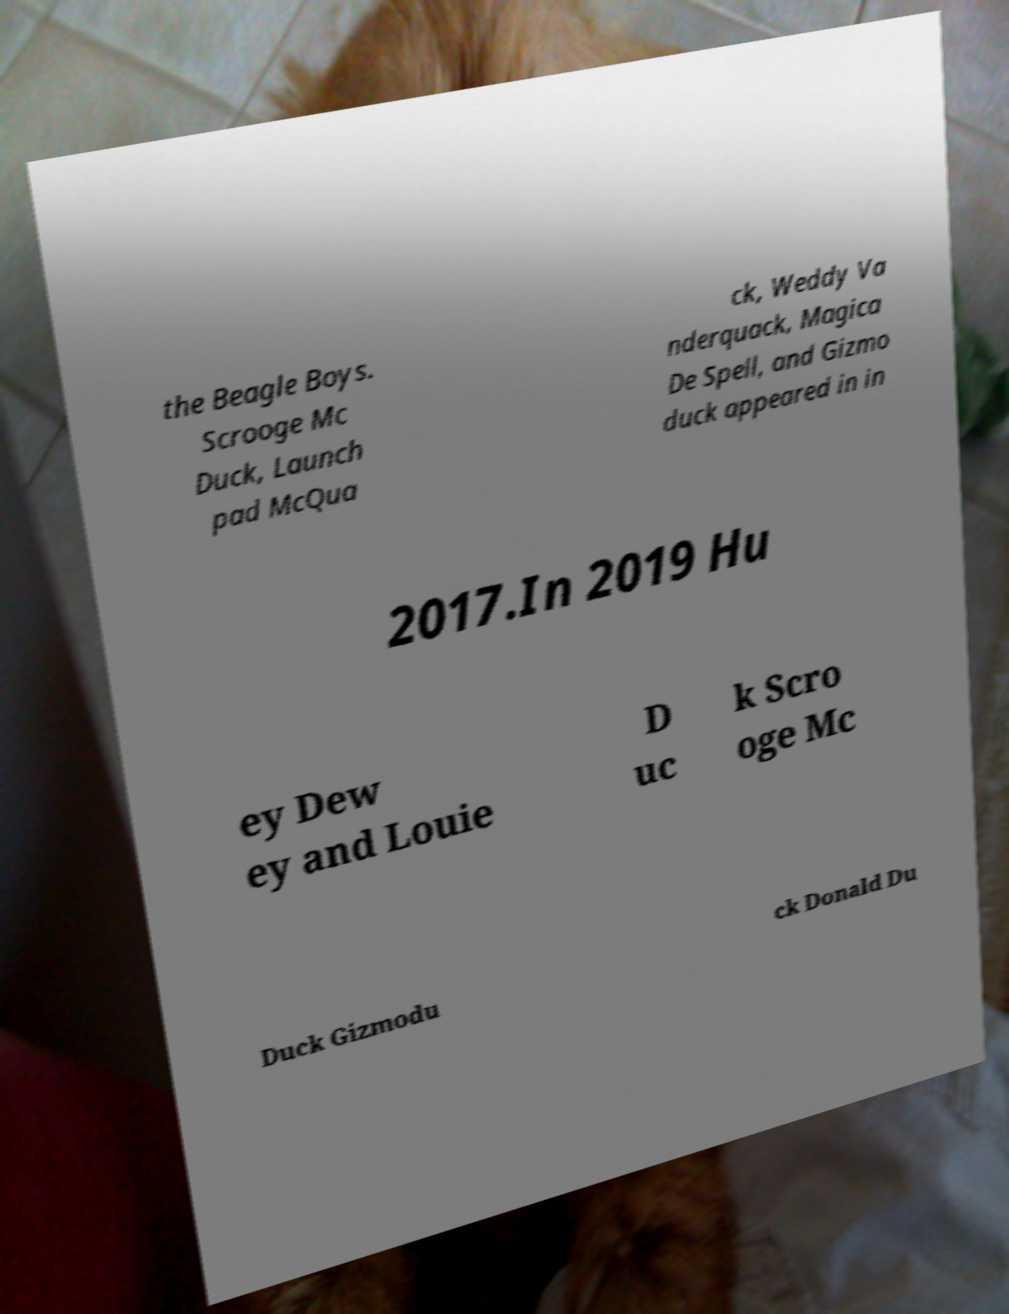Could you assist in decoding the text presented in this image and type it out clearly? the Beagle Boys. Scrooge Mc Duck, Launch pad McQua ck, Weddy Va nderquack, Magica De Spell, and Gizmo duck appeared in in 2017.In 2019 Hu ey Dew ey and Louie D uc k Scro oge Mc Duck Gizmodu ck Donald Du 